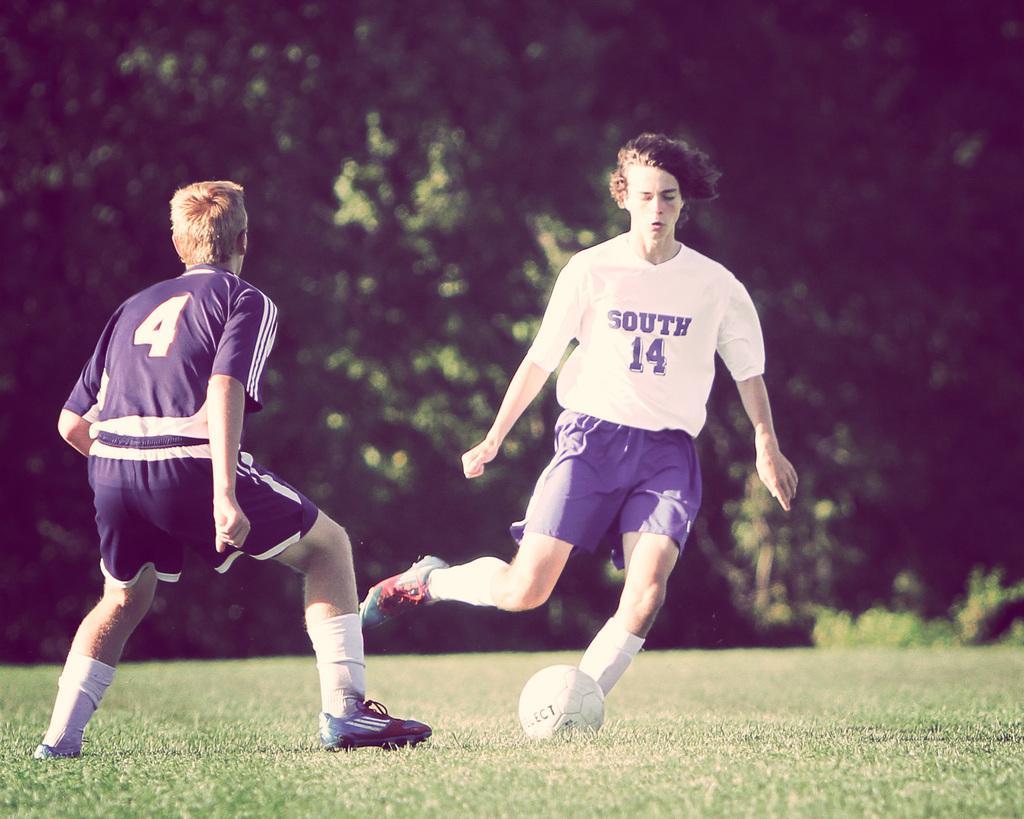Could you give a brief overview of what you see in this image? In this image there are two person playing a football in the garden. There is a ball. At the back side there are trees. 